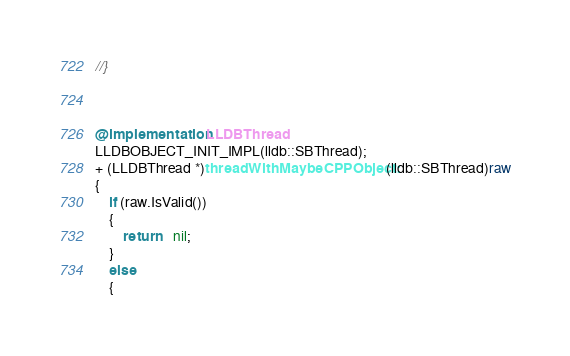Convert code to text. <code><loc_0><loc_0><loc_500><loc_500><_ObjectiveC_>//}



@implementation LLDBThread
LLDBOBJECT_INIT_IMPL(lldb::SBThread);
+ (LLDBThread *)threadWithMaybeCPPObject:(lldb::SBThread)raw
{
	if (raw.IsValid())
	{
		return	nil;
	}
	else
	{</code> 